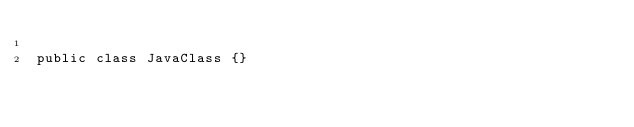<code> <loc_0><loc_0><loc_500><loc_500><_Java_>
public class JavaClass {}</code> 